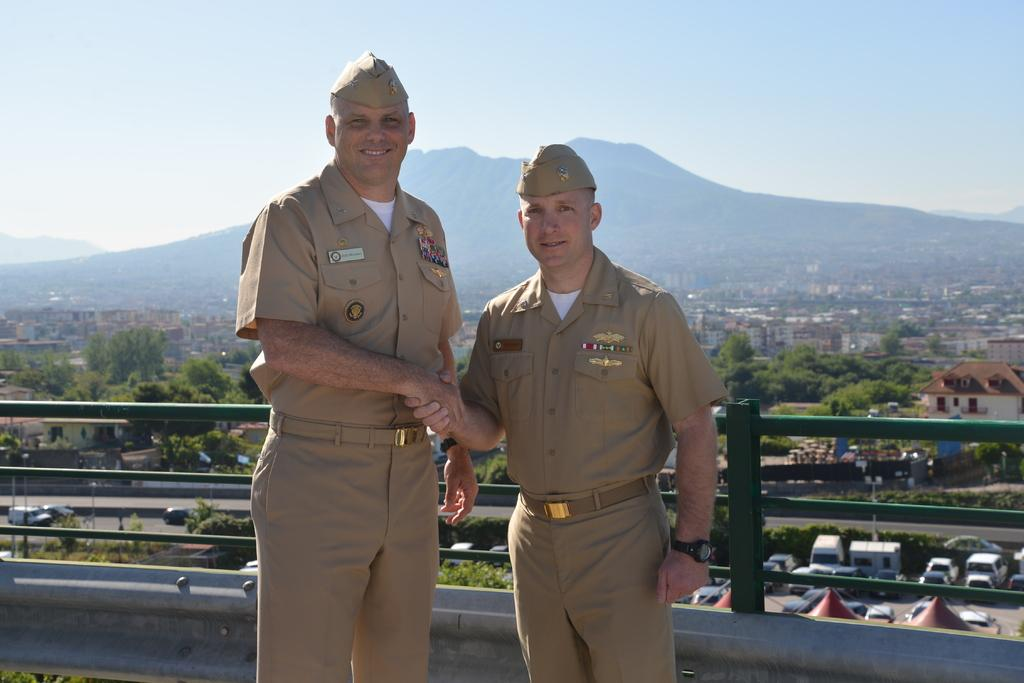How many men are in the image? There are two men in the image. What are the men wearing on their heads? The men are wearing caps. What are the men doing in the image? The men are standing and smiling. What type of structures can be seen in the image? There are buildings in the image. What type of vegetation is present in the image? There are trees in the image. What type of transportation is visible in the image? There are vehicles in the image. What type of natural landform is visible in the image? There are mountains in the image. What is visible in the background of the image? The sky is visible in the background of the image. What type of wood is being used to catch fish in the image? There is no wood or fishing activity present in the image. 